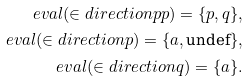Convert formula to latex. <formula><loc_0><loc_0><loc_500><loc_500>\ e v a l ( \in d i r e c t i o n p p ) = \{ p , q \} , \\ \ e v a l ( \in d i r e c t i o n p ) = \{ a , \text {undef} \} , \\ \ e v a l ( \in d i r e c t i o n q ) = \{ a \} .</formula> 